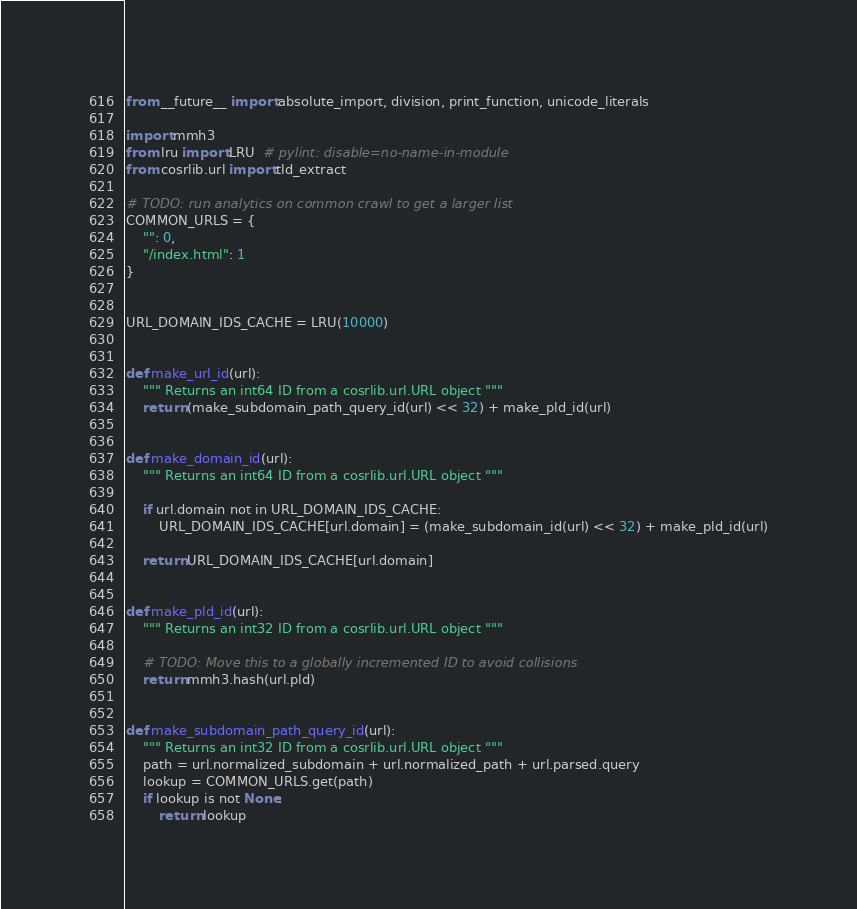Convert code to text. <code><loc_0><loc_0><loc_500><loc_500><_Python_>from __future__ import absolute_import, division, print_function, unicode_literals

import mmh3
from lru import LRU  # pylint: disable=no-name-in-module
from cosrlib.url import tld_extract

# TODO: run analytics on common crawl to get a larger list
COMMON_URLS = {
    "": 0,
    "/index.html": 1
}


URL_DOMAIN_IDS_CACHE = LRU(10000)


def make_url_id(url):
    """ Returns an int64 ID from a cosrlib.url.URL object """
    return (make_subdomain_path_query_id(url) << 32) + make_pld_id(url)


def make_domain_id(url):
    """ Returns an int64 ID from a cosrlib.url.URL object """

    if url.domain not in URL_DOMAIN_IDS_CACHE:
        URL_DOMAIN_IDS_CACHE[url.domain] = (make_subdomain_id(url) << 32) + make_pld_id(url)

    return URL_DOMAIN_IDS_CACHE[url.domain]


def make_pld_id(url):
    """ Returns an int32 ID from a cosrlib.url.URL object """

    # TODO: Move this to a globally incremented ID to avoid collisions
    return mmh3.hash(url.pld)


def make_subdomain_path_query_id(url):
    """ Returns an int32 ID from a cosrlib.url.URL object """
    path = url.normalized_subdomain + url.normalized_path + url.parsed.query
    lookup = COMMON_URLS.get(path)
    if lookup is not None:
        return lookup</code> 